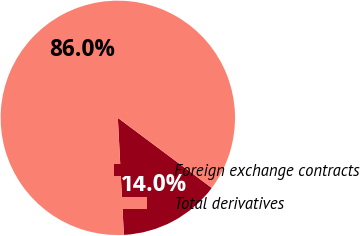Convert chart. <chart><loc_0><loc_0><loc_500><loc_500><pie_chart><fcel>Foreign exchange contracts<fcel>Total derivatives<nl><fcel>13.98%<fcel>86.02%<nl></chart> 